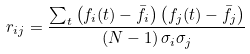<formula> <loc_0><loc_0><loc_500><loc_500>r _ { i j } = \frac { \sum _ { t } \left ( f _ { i } ( t ) - \bar { f _ { i } } \right ) \left ( f _ { j } ( t ) - \bar { f _ { j } } \right ) } { ( N - 1 ) \, \sigma _ { i } \sigma _ { j } }</formula> 